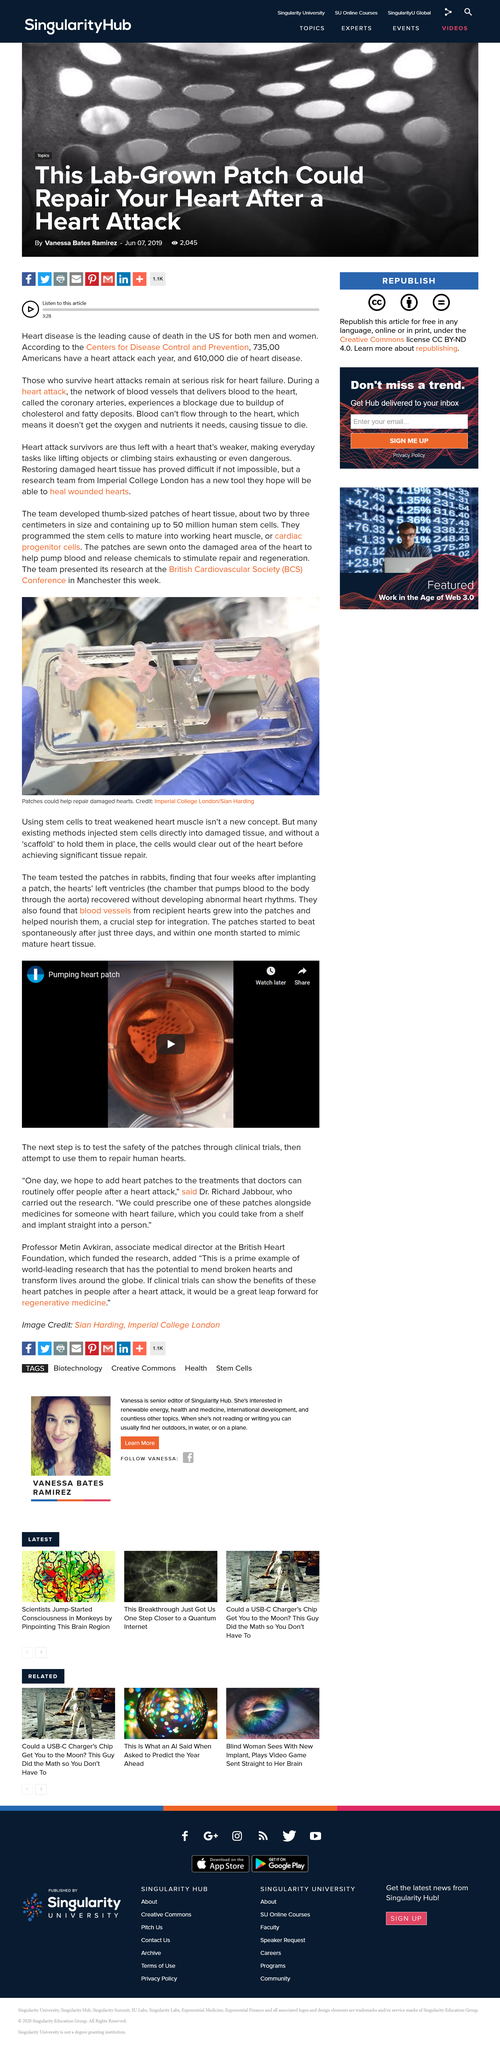Highlight a few significant elements in this photo. Declarative sentence: It is possible to use heart patches to treat heart attack victims, and in the future, doctors aim to incorporate heart patches as part of the available treatments for individuals who have experienced a heart attack. Existing methods of injecting stem cells into damaged tissue have been unsuccessful. STEM CELLS HAVE NOT REMAINED IN DAMAGED TISSUE BECAUSE THEY HAVE NOT HAD A SCAFFIELD (OR PATCH) TO HOLD THEM IN PLACE. Pumping heart patches are used to attempt to repair human hearts with damaged or weakened muscle tissue. Dr. Richard Jabbour conducted research on heart patches. 